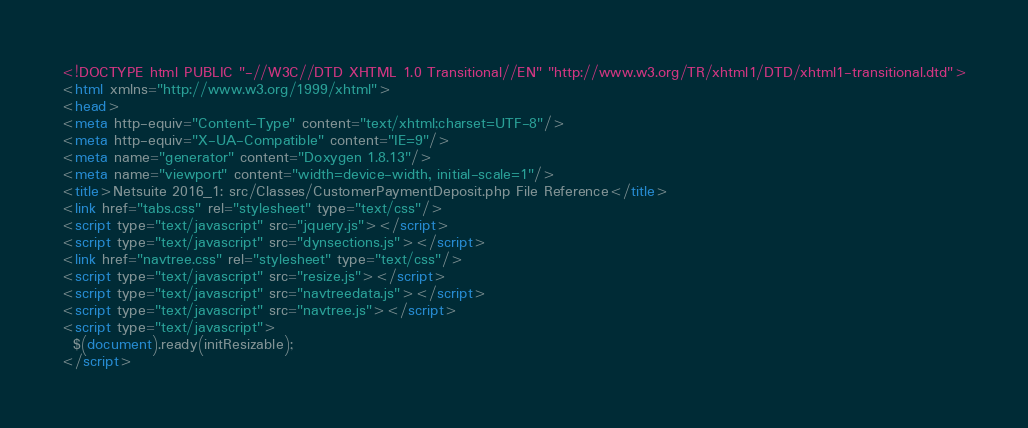Convert code to text. <code><loc_0><loc_0><loc_500><loc_500><_HTML_><!DOCTYPE html PUBLIC "-//W3C//DTD XHTML 1.0 Transitional//EN" "http://www.w3.org/TR/xhtml1/DTD/xhtml1-transitional.dtd">
<html xmlns="http://www.w3.org/1999/xhtml">
<head>
<meta http-equiv="Content-Type" content="text/xhtml;charset=UTF-8"/>
<meta http-equiv="X-UA-Compatible" content="IE=9"/>
<meta name="generator" content="Doxygen 1.8.13"/>
<meta name="viewport" content="width=device-width, initial-scale=1"/>
<title>Netsuite 2016_1: src/Classes/CustomerPaymentDeposit.php File Reference</title>
<link href="tabs.css" rel="stylesheet" type="text/css"/>
<script type="text/javascript" src="jquery.js"></script>
<script type="text/javascript" src="dynsections.js"></script>
<link href="navtree.css" rel="stylesheet" type="text/css"/>
<script type="text/javascript" src="resize.js"></script>
<script type="text/javascript" src="navtreedata.js"></script>
<script type="text/javascript" src="navtree.js"></script>
<script type="text/javascript">
  $(document).ready(initResizable);
</script></code> 